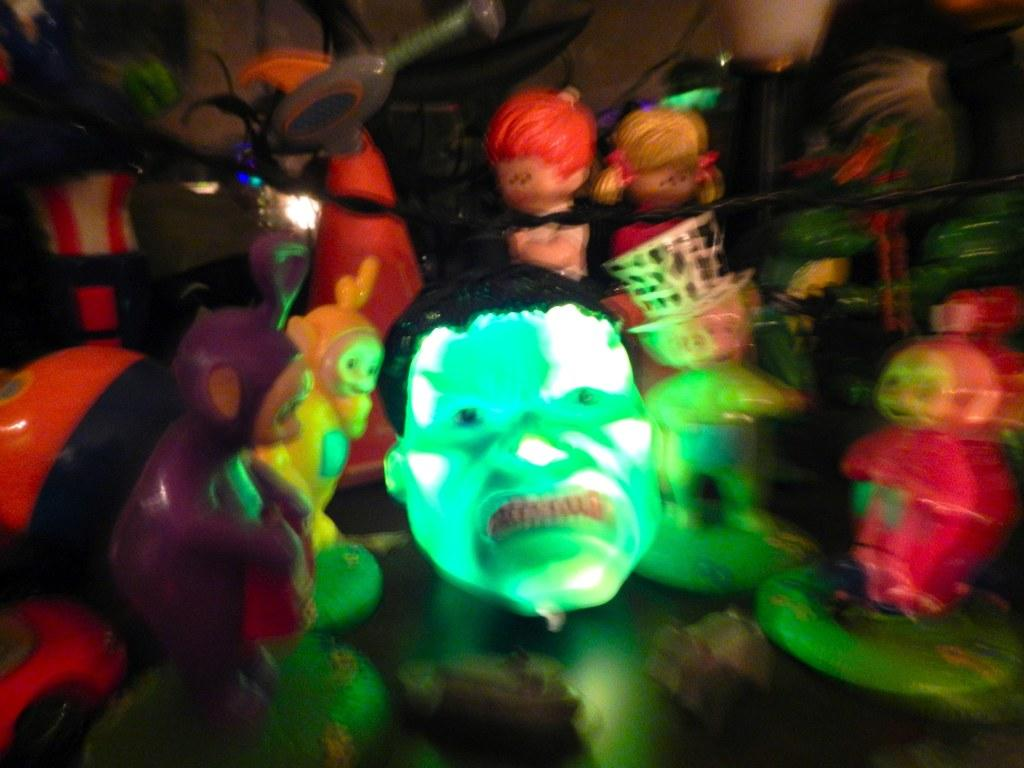What is the main subject in the foreground of the image? There are many toys in the foreground of the image. Can you describe a specific toy in the image? There is a man face toy in green color in the center of the image. What type of jeans is the man wearing in the image? There is no man present in the image, only toys. 